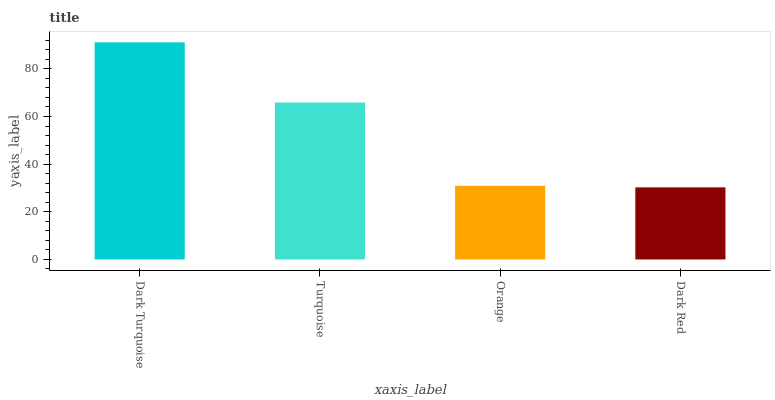Is Dark Red the minimum?
Answer yes or no. Yes. Is Dark Turquoise the maximum?
Answer yes or no. Yes. Is Turquoise the minimum?
Answer yes or no. No. Is Turquoise the maximum?
Answer yes or no. No. Is Dark Turquoise greater than Turquoise?
Answer yes or no. Yes. Is Turquoise less than Dark Turquoise?
Answer yes or no. Yes. Is Turquoise greater than Dark Turquoise?
Answer yes or no. No. Is Dark Turquoise less than Turquoise?
Answer yes or no. No. Is Turquoise the high median?
Answer yes or no. Yes. Is Orange the low median?
Answer yes or no. Yes. Is Dark Turquoise the high median?
Answer yes or no. No. Is Dark Turquoise the low median?
Answer yes or no. No. 